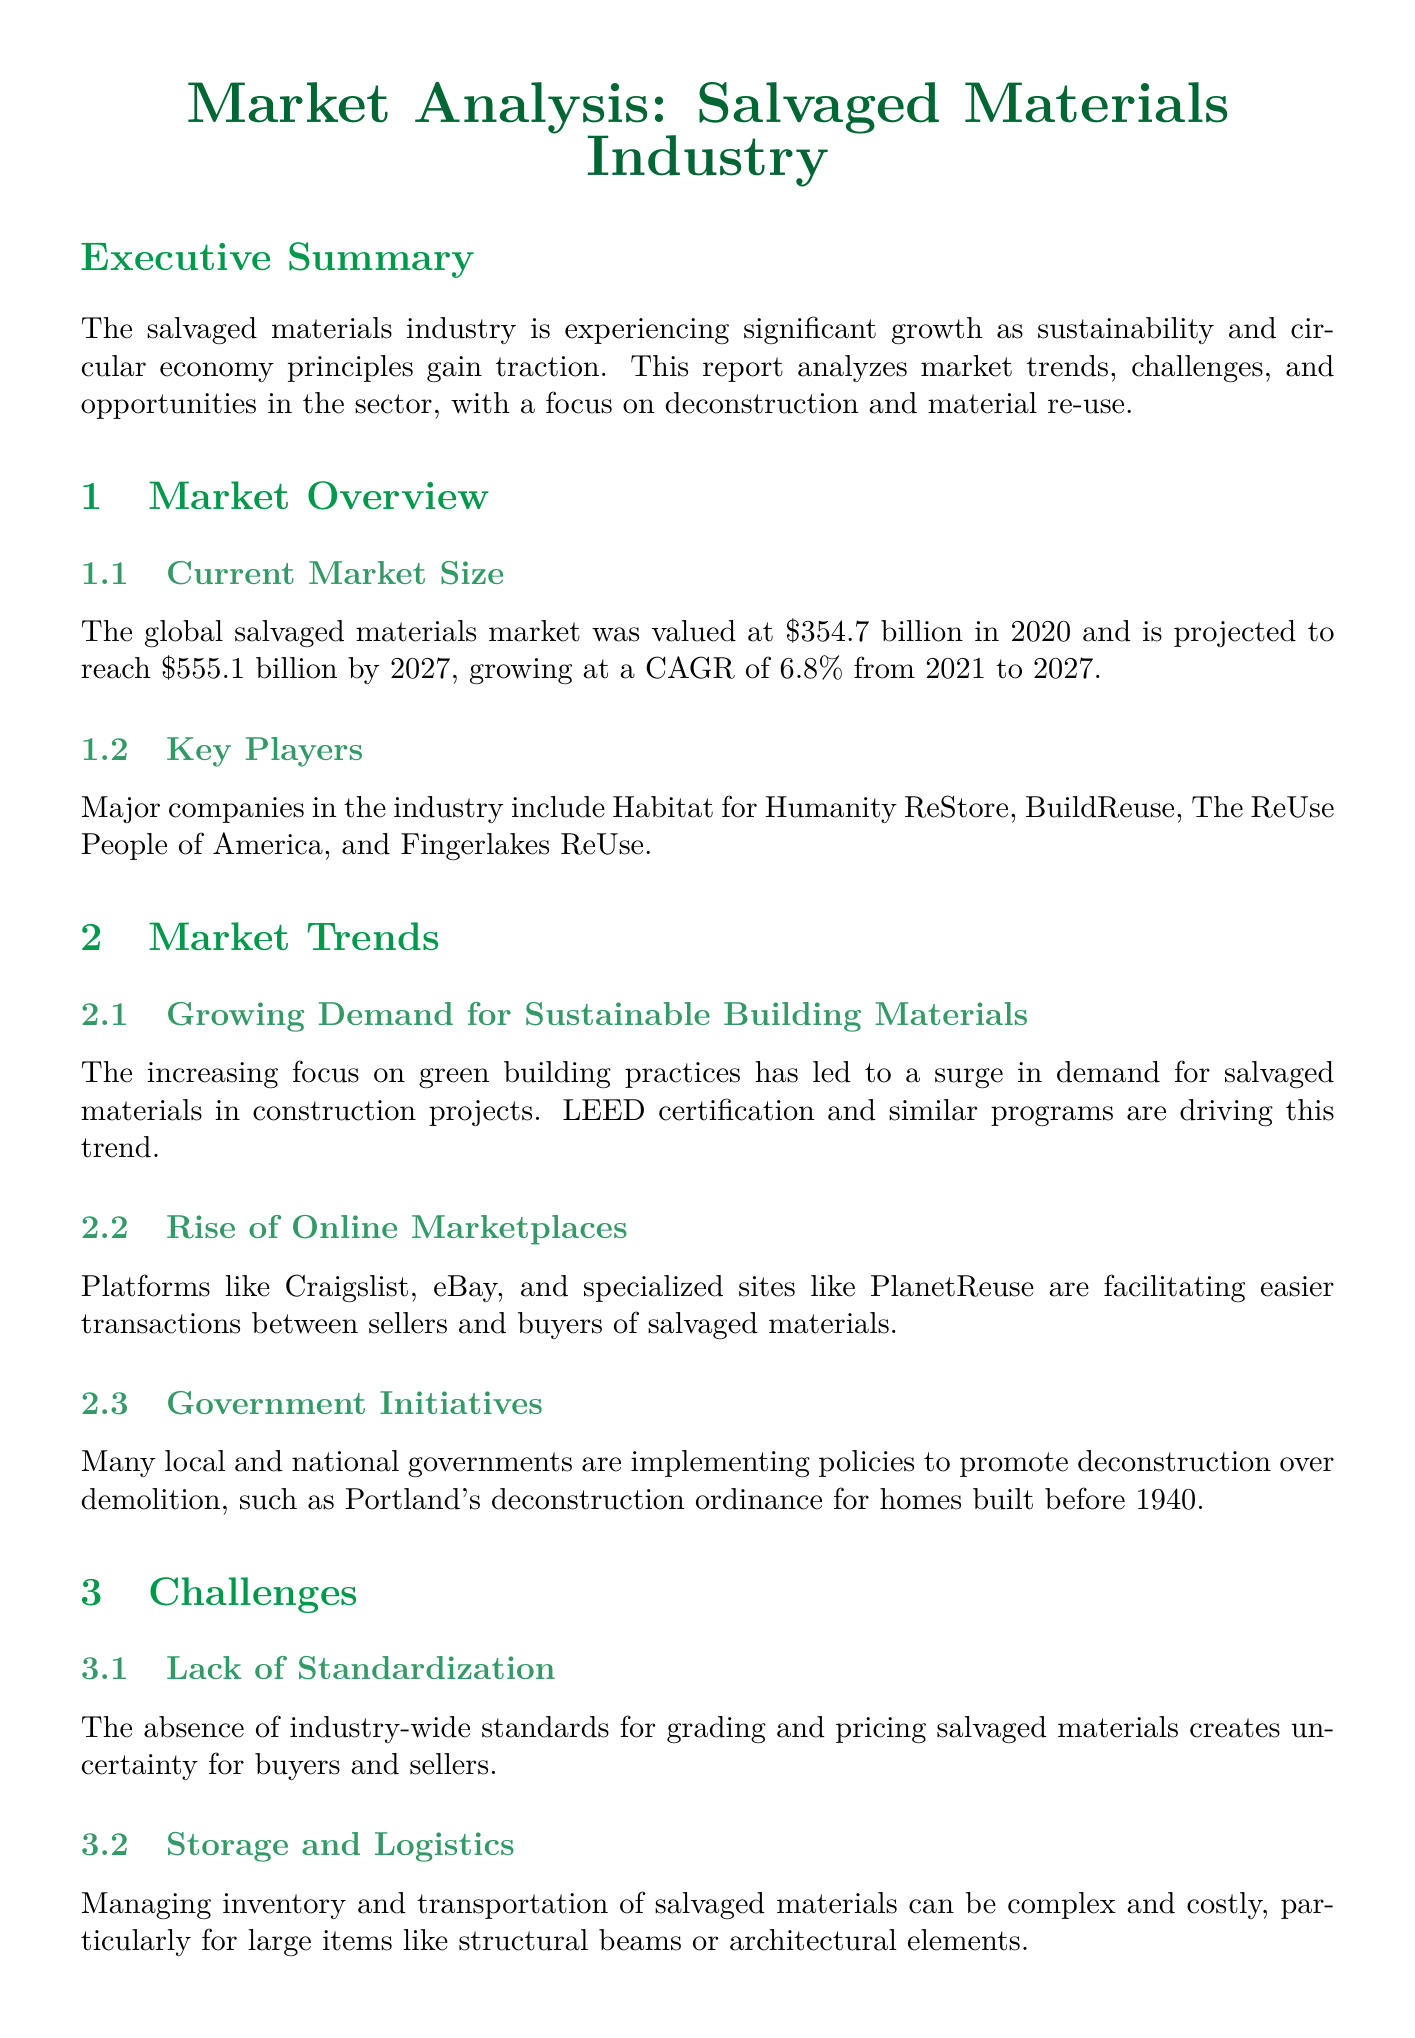What was the global salvaged materials market value in 2020? The document states that the global salvaged materials market was valued at $354.7 billion in 2020.
Answer: $354.7 billion What is the projected market size by 2027? The report mentions that the market is projected to reach $555.1 billion by 2027.
Answer: $555.1 billion What is the annual growth rate (CAGR) from 2021 to 2027? The document specifies a CAGR of 6.8% from 2021 to 2027.
Answer: 6.8% Who is one of the major companies in the industry? The report lists Habitat for Humanity ReStore as a major company in the salvaged materials industry.
Answer: Habitat for Humanity ReStore What kind of programs are driving the demand for salvaged materials? The increasing focus on green building practices and LEED certification are driving demand for salvaged materials.
Answer: LEED certification What is a significant challenge faced by the salvaged materials industry? The document highlights the lack of standardization as a significant challenge.
Answer: Lack of Standardization What technological innovation can improve inventory management? The report mentions that AI can improve inventory management in the salvaged materials industry.
Answer: AI What is a case study mentioned in the report? The Delta Institute's Rebuilding Exchange is presented as a case study in the document.
Answer: Delta Institute's Rebuilding Exchange What recommendation is made regarding education? The document recommends investing in workforce development programs to address the skills gap.
Answer: Invest in workforce development programs 